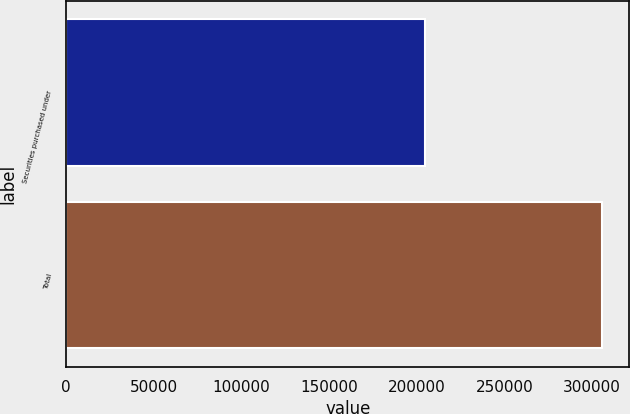Convert chart. <chart><loc_0><loc_0><loc_500><loc_500><bar_chart><fcel>Securities purchased under<fcel>Total<nl><fcel>204460<fcel>305954<nl></chart> 